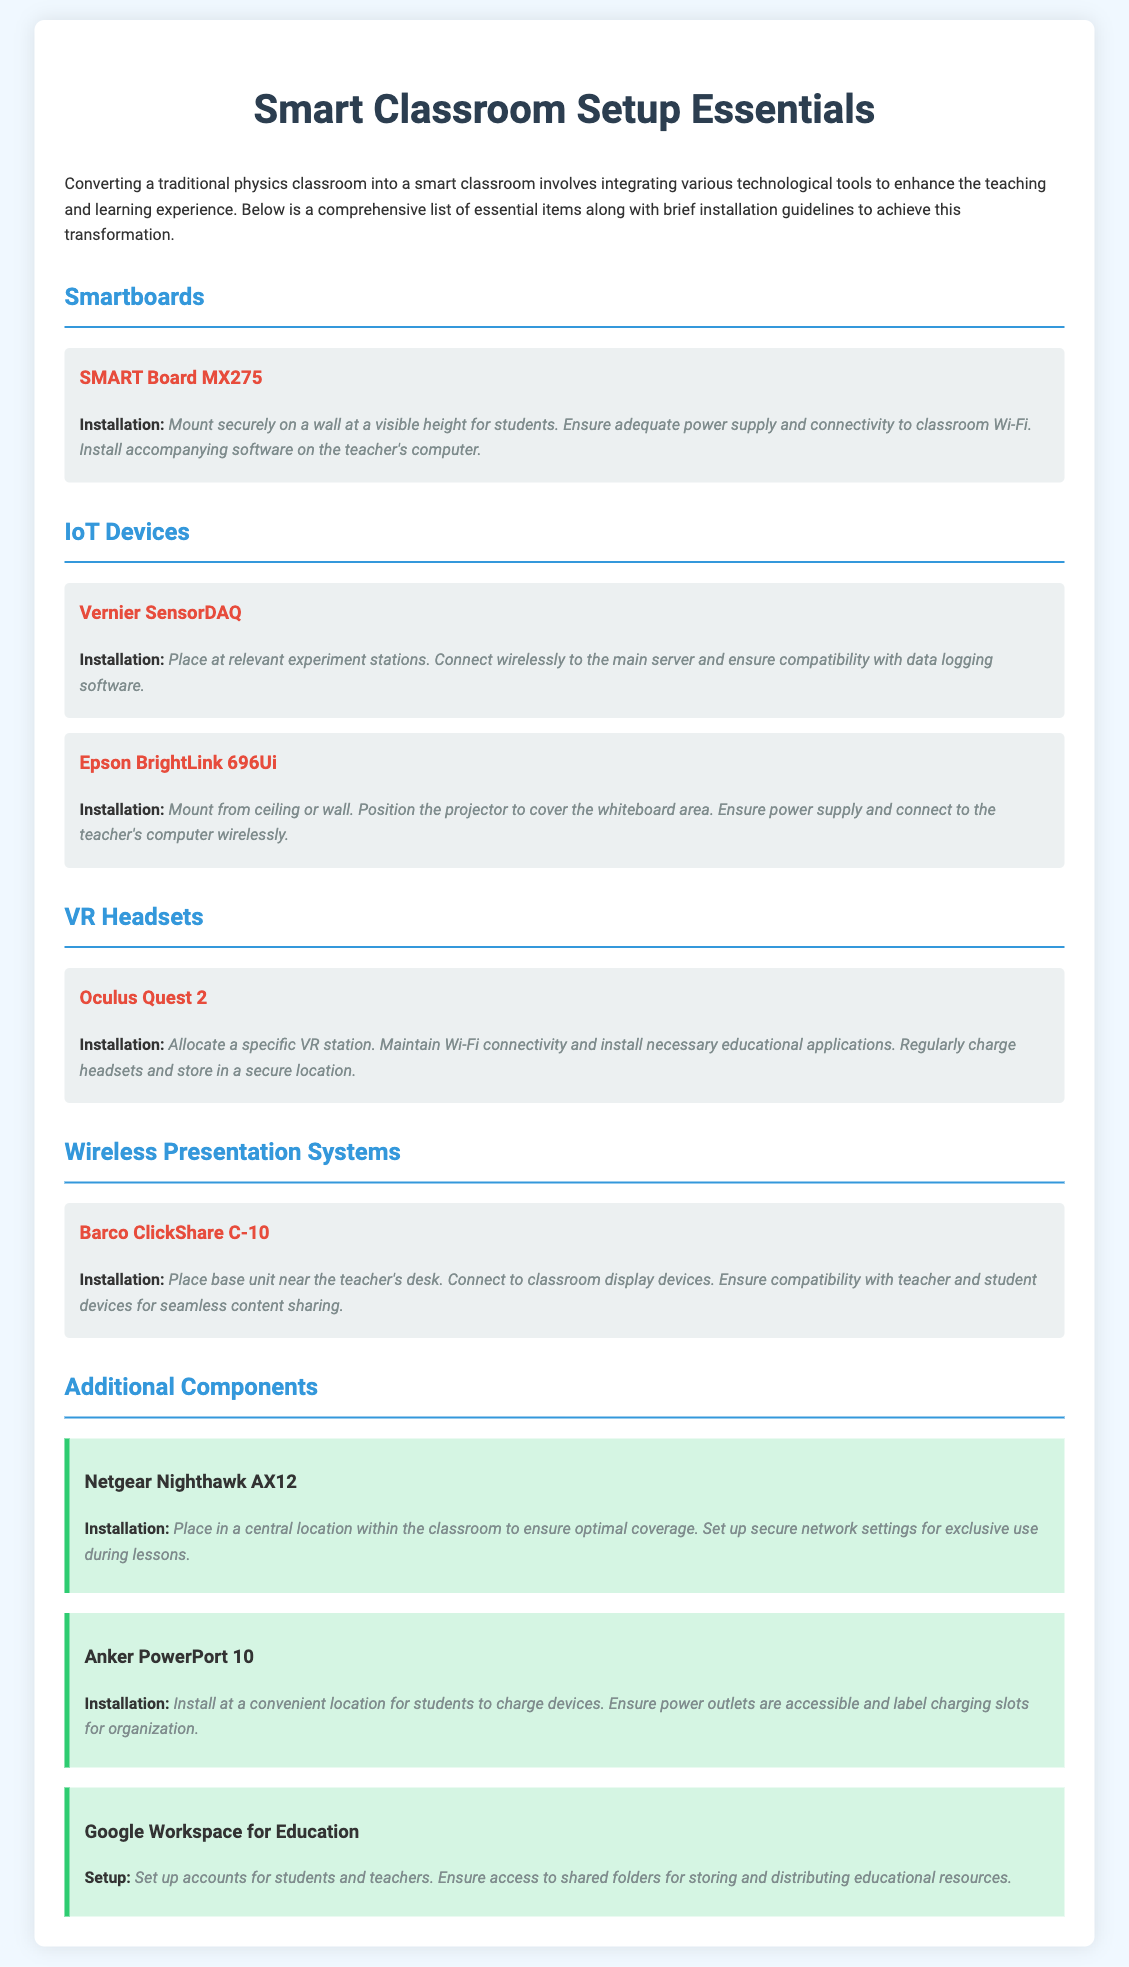What is the main title of the document? The main title is prominently displayed at the top of the document and is "Smart Classroom Setup Essentials."
Answer: Smart Classroom Setup Essentials How many types of smart technology are listed in the document? The document categorizes items into four distinct types: Smartboards, IoT Devices, VR Headsets, and Wireless Presentation Systems.
Answer: Four What is one example of a VR headset mentioned? The document provides specific examples of items, including "Oculus Quest 2" under the VR Headsets section.
Answer: Oculus Quest 2 What item needs to be mounted securely on a wall? The document specifies that the "SMART Board MX275" should be mounted securely on a wall for visibility.
Answer: SMART Board MX275 What is suggested for maintaining the VR headsets? The document mentions the importance of regularly charging and securely storing the VR headsets.
Answer: Regularly charge headsets What device should be placed near the teacher's desk? The document specifically instructs to place the "Barco ClickShare C-10" near the teacher's desk for optimal use.
Answer: Barco ClickShare C-10 What installation guideline is provided for the Netgear Nighthawk AX12? The document advises placing the Netgear Nighthawk AX12 in a central location for optimal coverage.
Answer: Central location How many Anker PowerPort 10 should be installed? The document does not specify a quantity; it discusses the installation of one Anker PowerPort 10 at a convenient charging location.
Answer: One What is a component essential for educational resources storage? The document includes "Google Workspace for Education" as a key component for storing and sharing educational resources.
Answer: Google Workspace for Education 